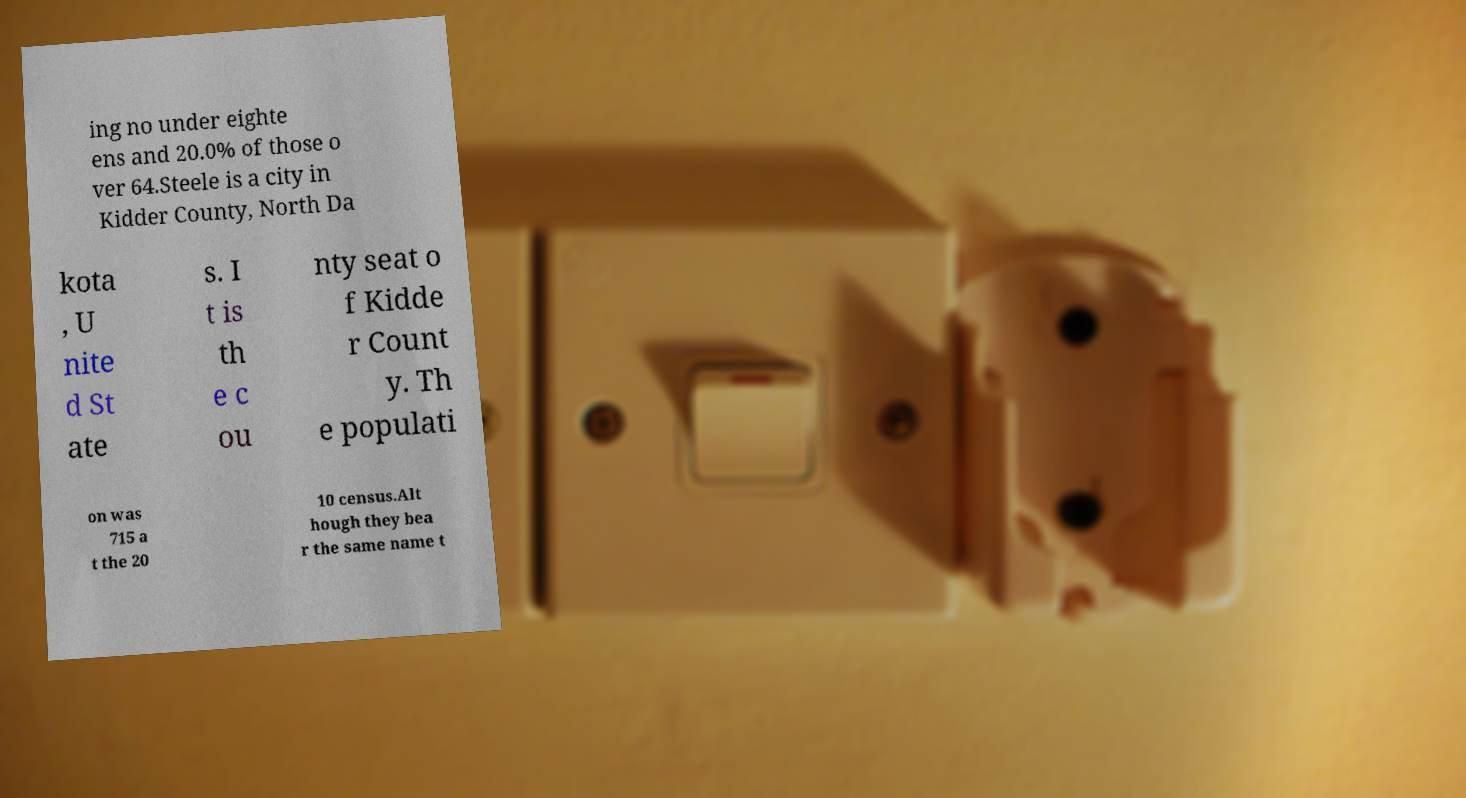Could you assist in decoding the text presented in this image and type it out clearly? ing no under eighte ens and 20.0% of those o ver 64.Steele is a city in Kidder County, North Da kota , U nite d St ate s. I t is th e c ou nty seat o f Kidde r Count y. Th e populati on was 715 a t the 20 10 census.Alt hough they bea r the same name t 